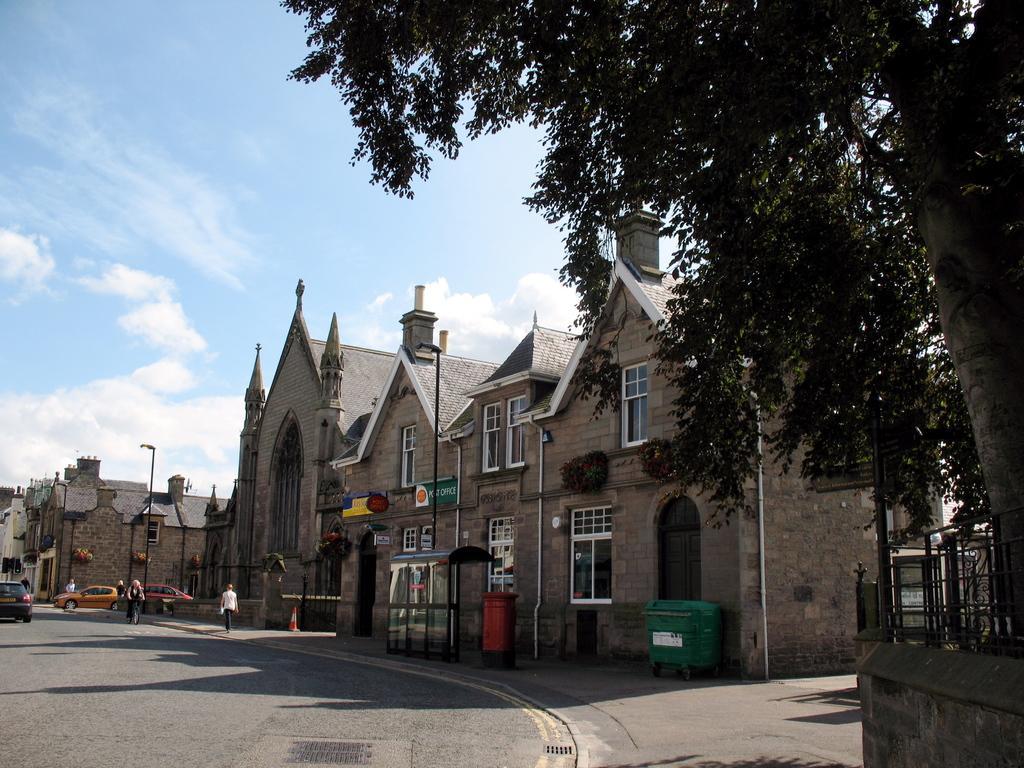What is the main feature of the image? There is a road in the image. What is happening on the road? Cars are moving on the road. What can be seen on the right side of the image? There are buildings and trees on the right side of the image. What is visible in the background of the image? There are clouds and the sky visible in the background of the image. What is the rate of the arch in the image? There is no arch present in the image, so it is not possible to determine a rate. 